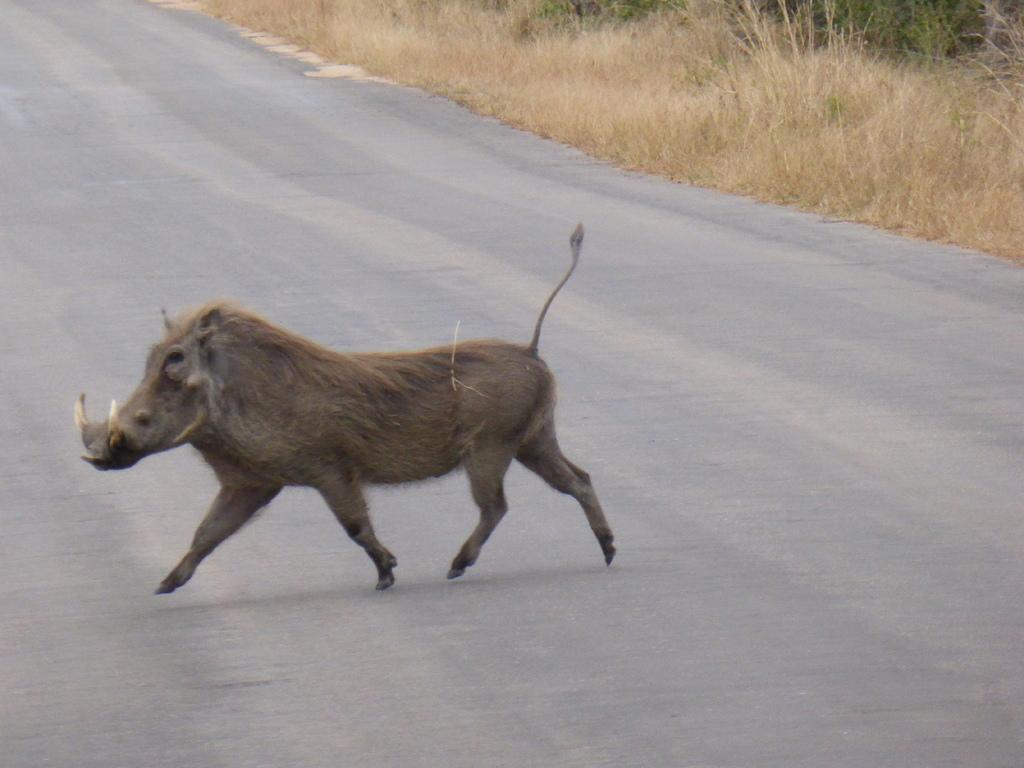What is on the road in the image? There is an animal on the road in the image. What can be seen in the background of the image? There is grass visible in the background of the image. Is there a boat sailing in the background of the image? No, there is no boat present in the image. Can you see a man walking on the grass in the background? No, there is no man present in the image. 